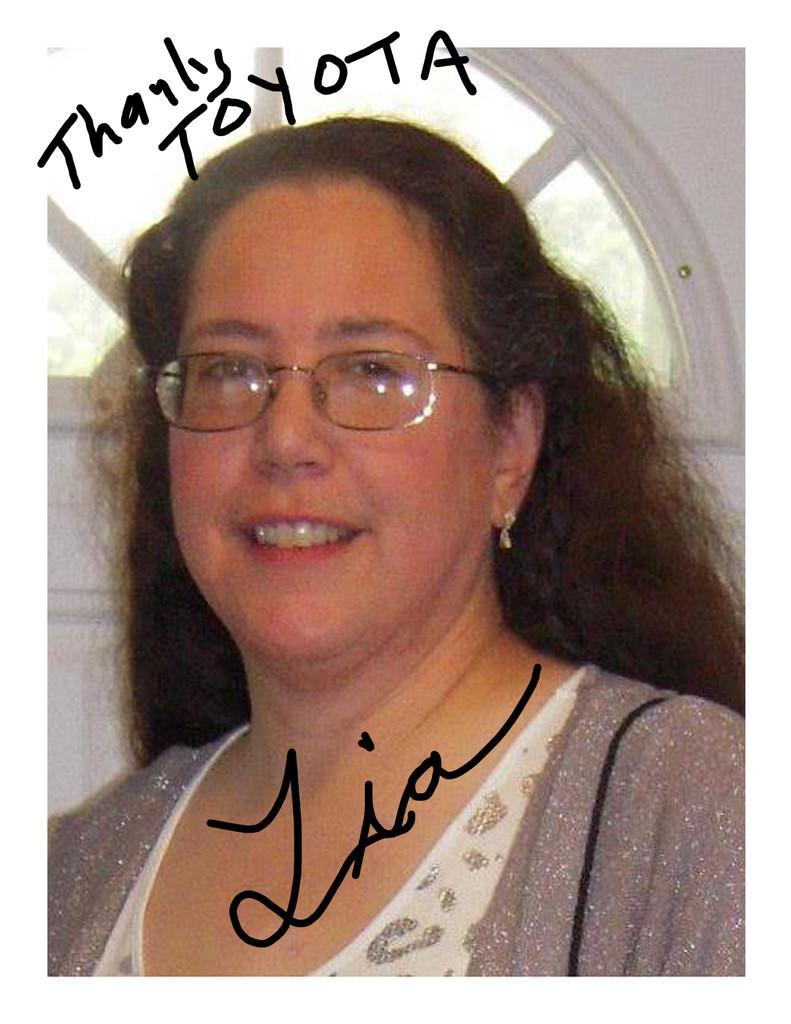In one or two sentences, can you explain what this image depicts? In this image we can see a woman smiling and some text. In the background there are trees and a window. 